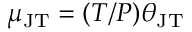<formula> <loc_0><loc_0><loc_500><loc_500>\mu _ { J T } = ( T / P ) \theta _ { J T }</formula> 